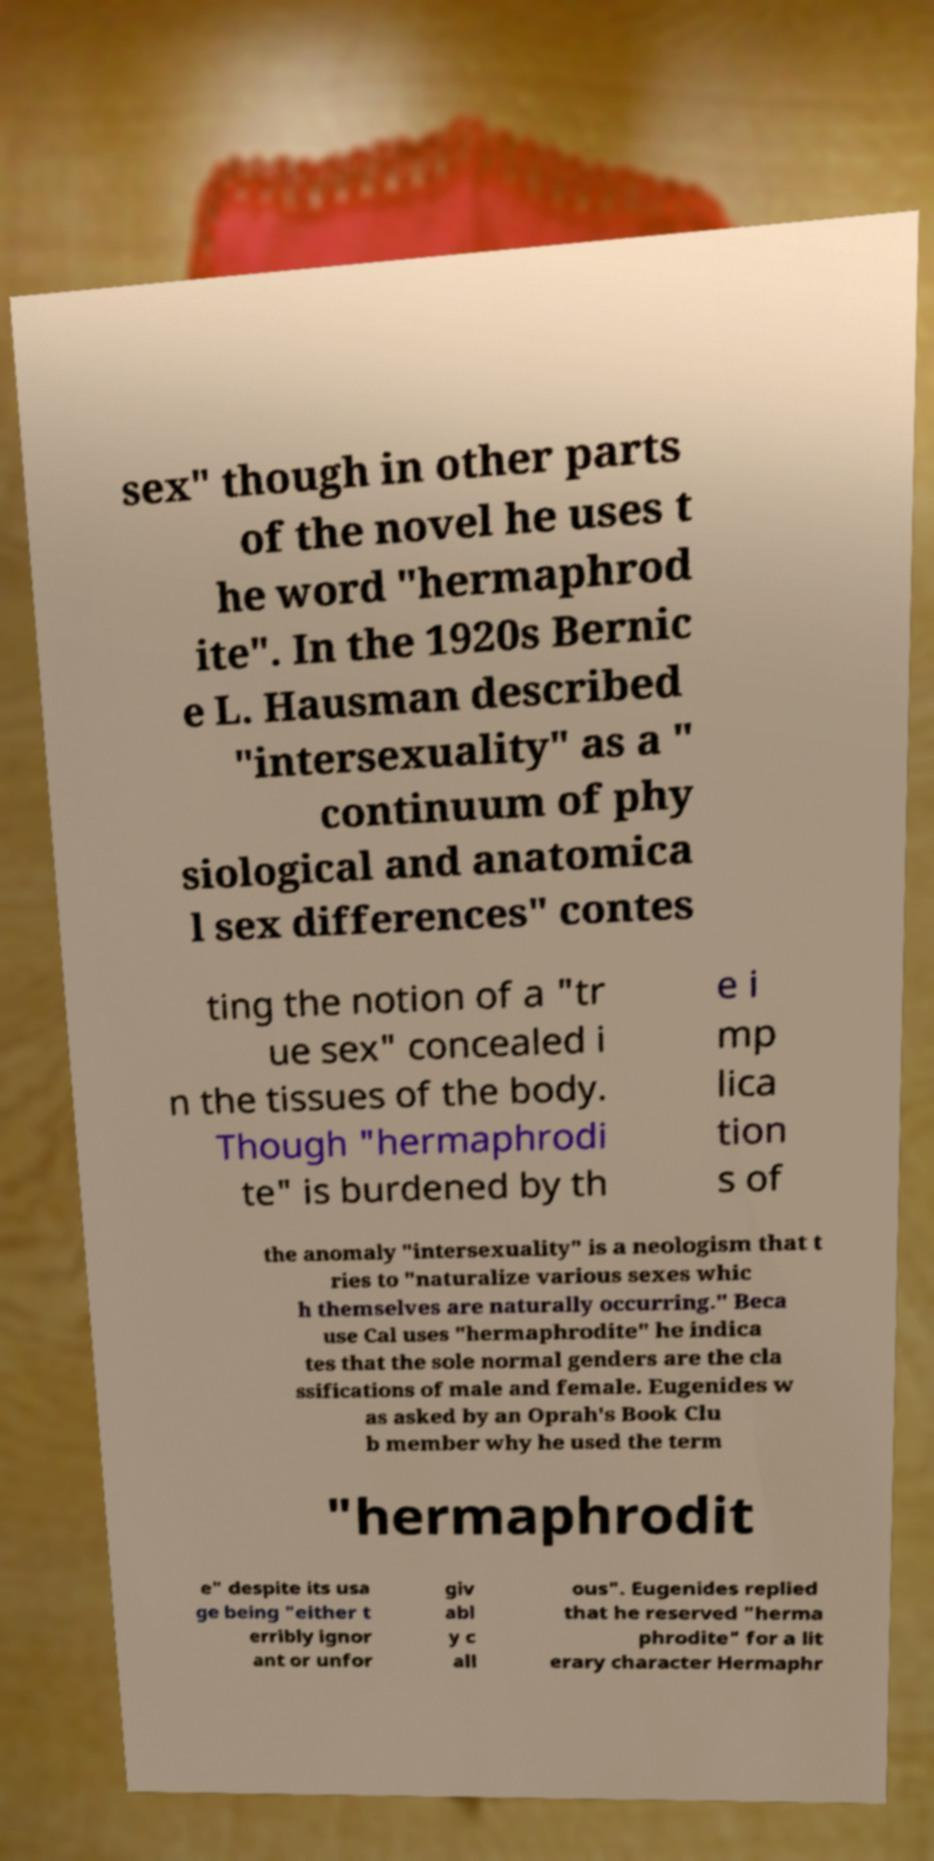What messages or text are displayed in this image? I need them in a readable, typed format. sex" though in other parts of the novel he uses t he word "hermaphrod ite". In the 1920s Bernic e L. Hausman described "intersexuality" as a " continuum of phy siological and anatomica l sex differences" contes ting the notion of a "tr ue sex" concealed i n the tissues of the body. Though "hermaphrodi te" is burdened by th e i mp lica tion s of the anomaly "intersexuality" is a neologism that t ries to "naturalize various sexes whic h themselves are naturally occurring." Beca use Cal uses "hermaphrodite" he indica tes that the sole normal genders are the cla ssifications of male and female. Eugenides w as asked by an Oprah's Book Clu b member why he used the term "hermaphrodit e" despite its usa ge being "either t erribly ignor ant or unfor giv abl y c all ous". Eugenides replied that he reserved "herma phrodite" for a lit erary character Hermaphr 